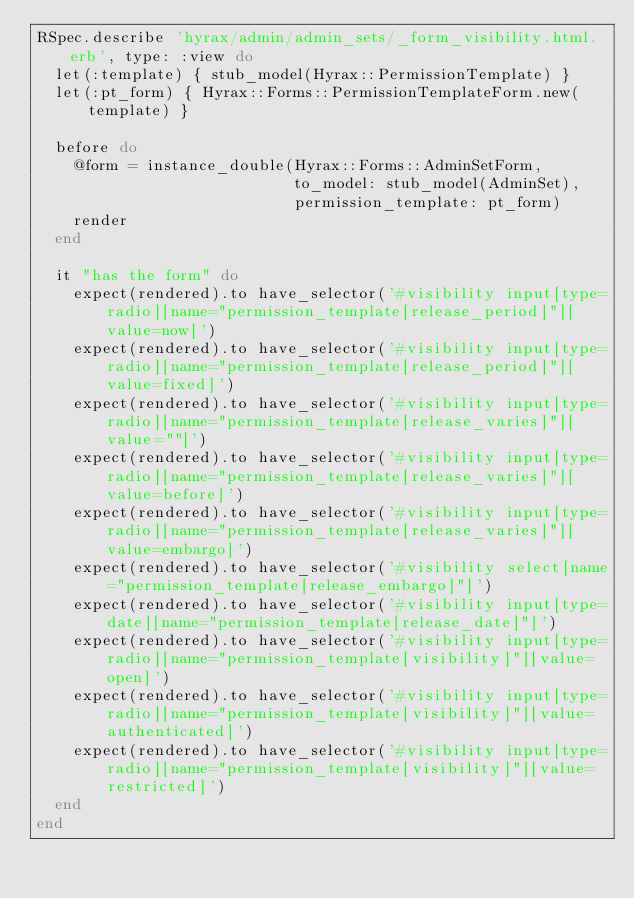<code> <loc_0><loc_0><loc_500><loc_500><_Ruby_>RSpec.describe 'hyrax/admin/admin_sets/_form_visibility.html.erb', type: :view do
  let(:template) { stub_model(Hyrax::PermissionTemplate) }
  let(:pt_form) { Hyrax::Forms::PermissionTemplateForm.new(template) }

  before do
    @form = instance_double(Hyrax::Forms::AdminSetForm,
                            to_model: stub_model(AdminSet),
                            permission_template: pt_form)
    render
  end

  it "has the form" do
    expect(rendered).to have_selector('#visibility input[type=radio][name="permission_template[release_period]"][value=now]')
    expect(rendered).to have_selector('#visibility input[type=radio][name="permission_template[release_period]"][value=fixed]')
    expect(rendered).to have_selector('#visibility input[type=radio][name="permission_template[release_varies]"][value=""]')
    expect(rendered).to have_selector('#visibility input[type=radio][name="permission_template[release_varies]"][value=before]')
    expect(rendered).to have_selector('#visibility input[type=radio][name="permission_template[release_varies]"][value=embargo]')
    expect(rendered).to have_selector('#visibility select[name="permission_template[release_embargo]"]')
    expect(rendered).to have_selector('#visibility input[type=date][name="permission_template[release_date]"]')
    expect(rendered).to have_selector('#visibility input[type=radio][name="permission_template[visibility]"][value=open]')
    expect(rendered).to have_selector('#visibility input[type=radio][name="permission_template[visibility]"][value=authenticated]')
    expect(rendered).to have_selector('#visibility input[type=radio][name="permission_template[visibility]"][value=restricted]')
  end
end
</code> 